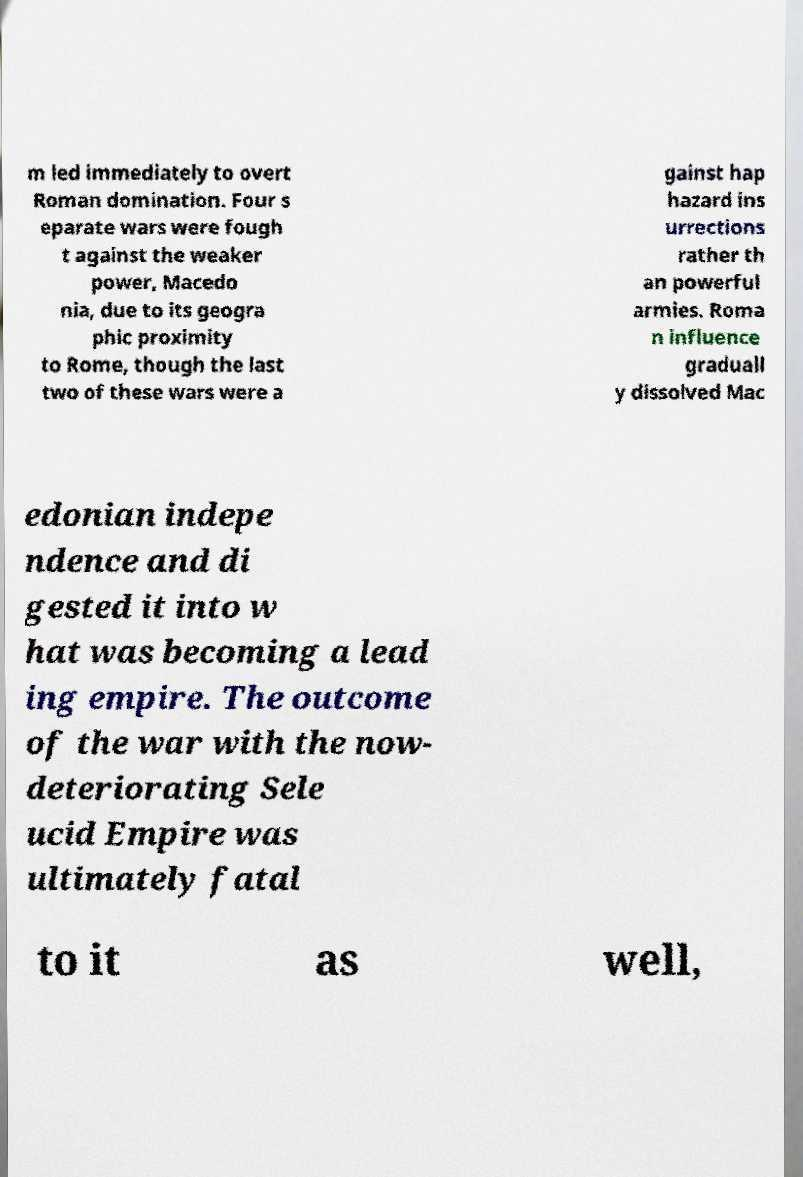Can you accurately transcribe the text from the provided image for me? m led immediately to overt Roman domination. Four s eparate wars were fough t against the weaker power, Macedo nia, due to its geogra phic proximity to Rome, though the last two of these wars were a gainst hap hazard ins urrections rather th an powerful armies. Roma n influence graduall y dissolved Mac edonian indepe ndence and di gested it into w hat was becoming a lead ing empire. The outcome of the war with the now- deteriorating Sele ucid Empire was ultimately fatal to it as well, 